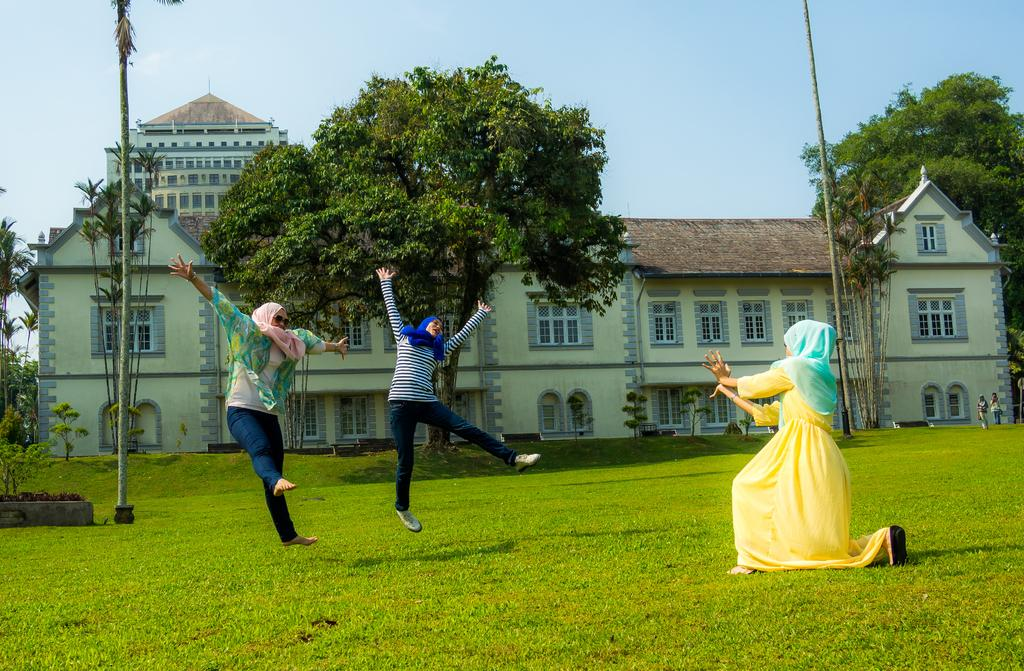How many people are in the image? There are three ladies in the image. What are the ladies wearing around their necks? The ladies are wearing scarves. What type of surface is under the ladies' feet? There is grass on the ground in the image. What can be seen in the background of the image? There is a building with windows and trees in the background. What is visible above the ladies and the background? The sky is visible in the image. Where is the faucet located in the image? There is no faucet present in the image. What type of organization do the ladies belong to in the image? There is no information about the ladies' affiliations or any organization in the image. 